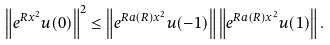Convert formula to latex. <formula><loc_0><loc_0><loc_500><loc_500>\left \| e ^ { R x ^ { 2 } } u ( 0 ) \right \| ^ { 2 } \leq \left \| e ^ { R a ( R ) x ^ { 2 } } u ( - 1 ) \right \| \left \| e ^ { R a ( R ) x ^ { 2 } } u ( 1 ) \right \| .</formula> 